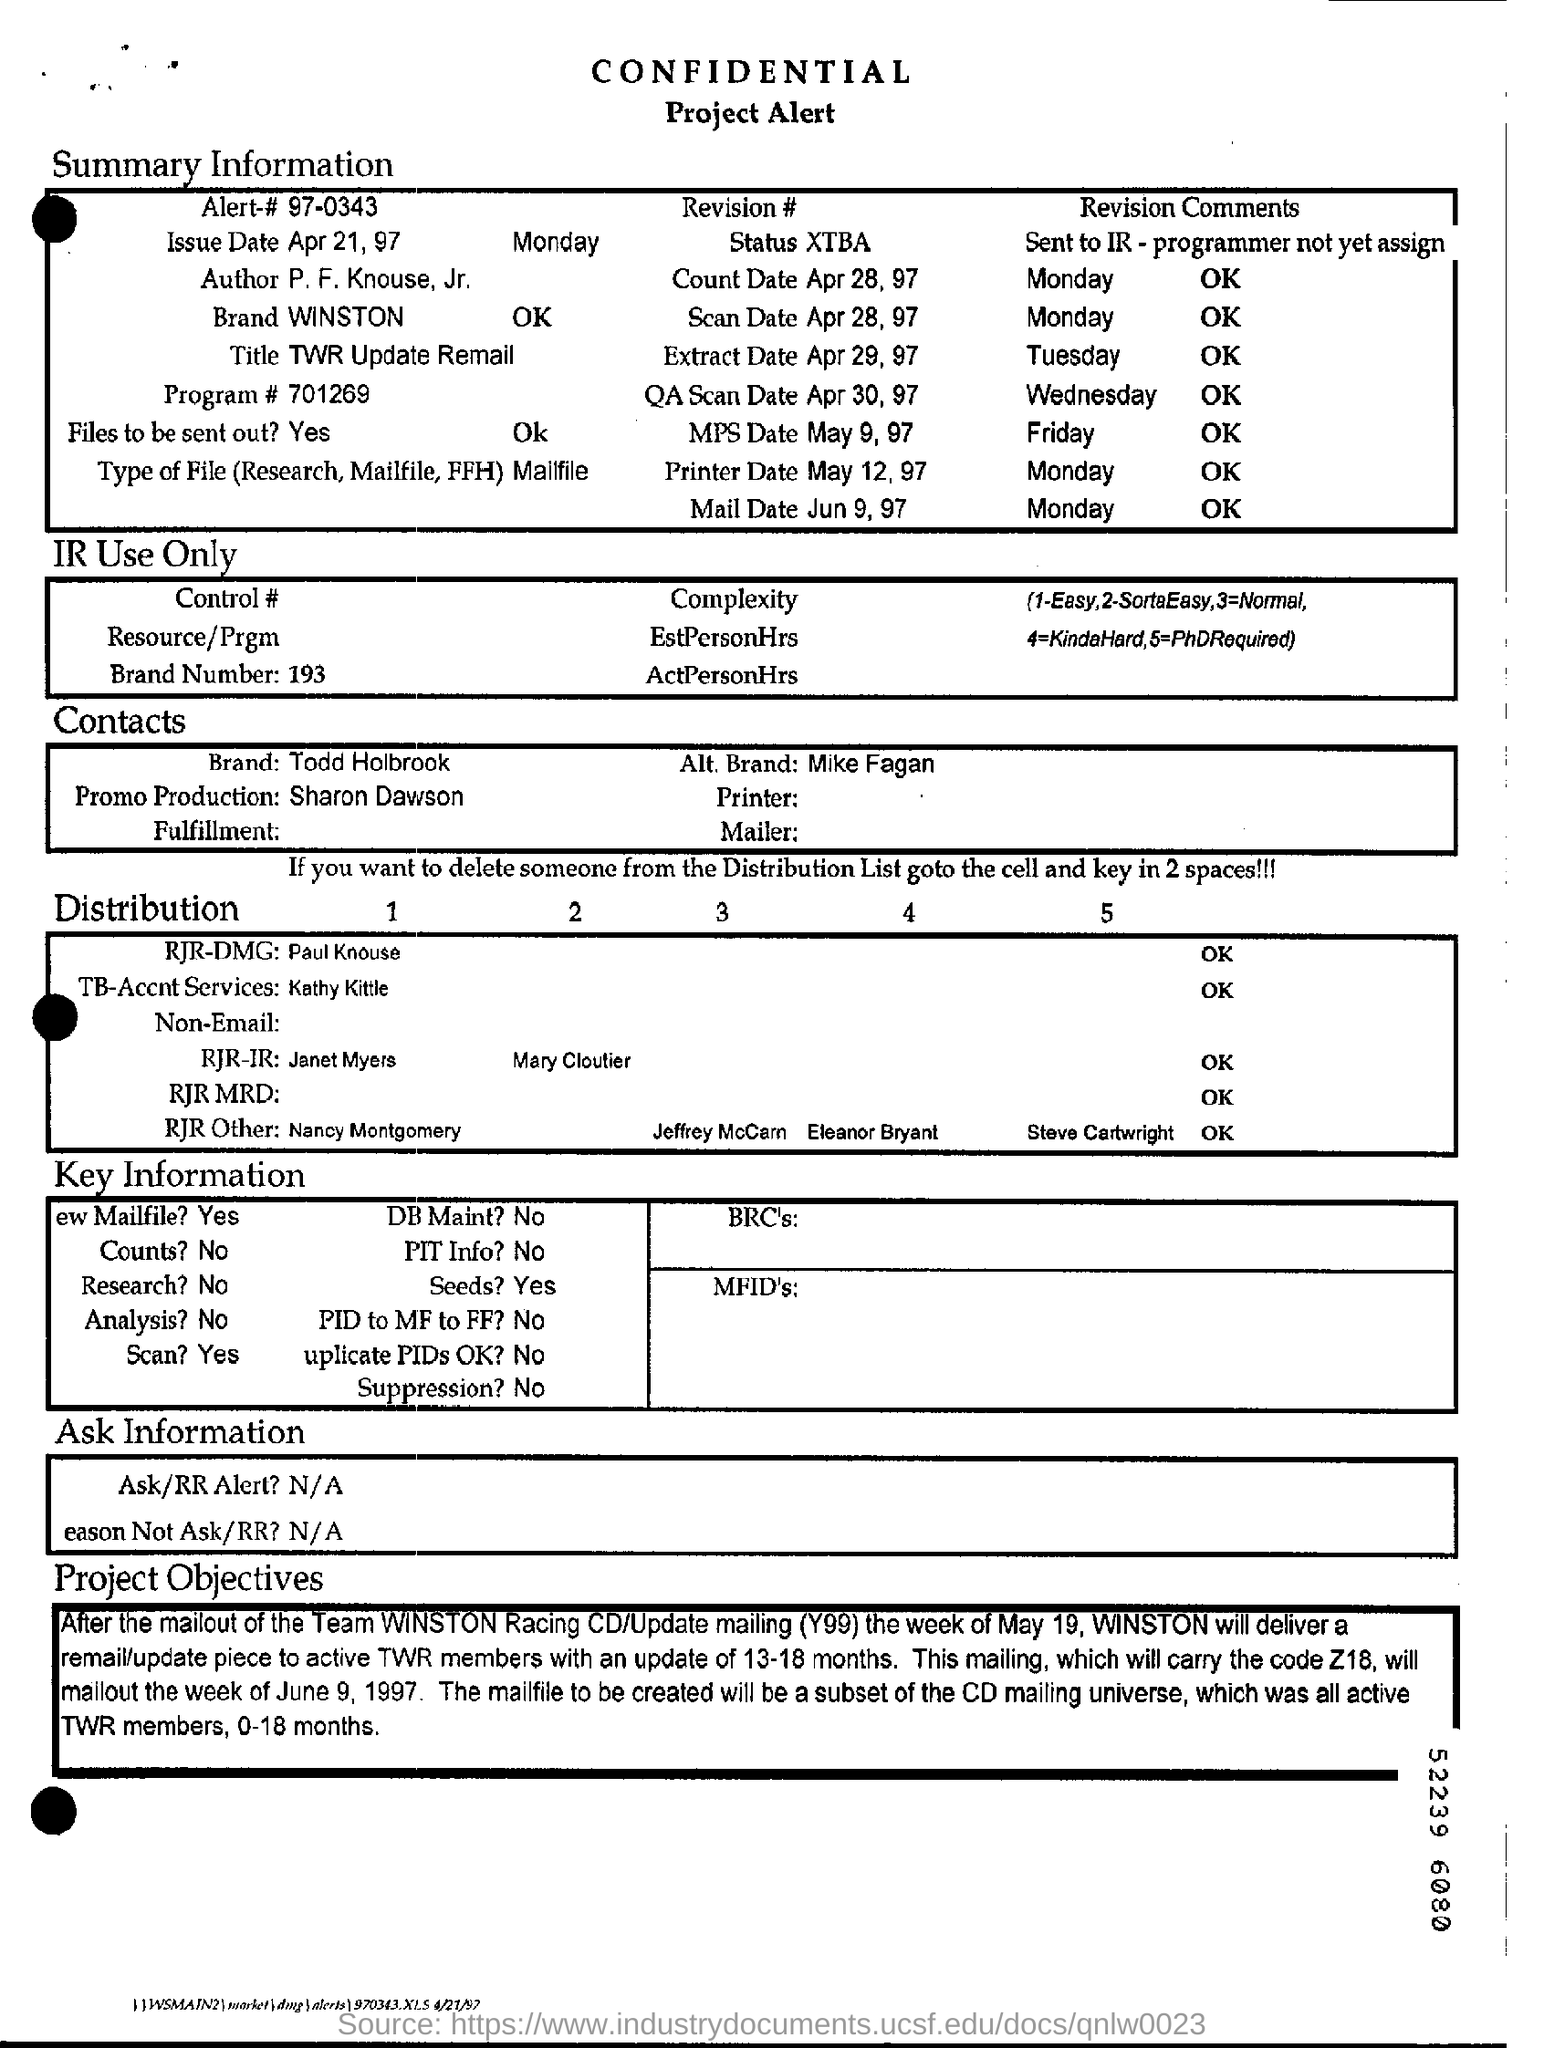What is the title under summary information
Ensure brevity in your answer.  TWR update remail. 